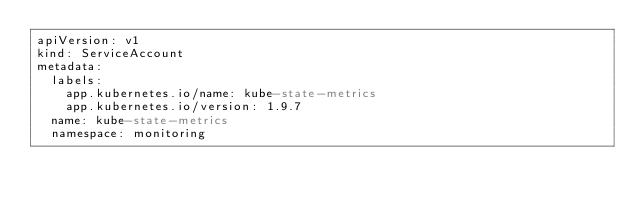<code> <loc_0><loc_0><loc_500><loc_500><_YAML_>apiVersion: v1
kind: ServiceAccount
metadata:
  labels:
    app.kubernetes.io/name: kube-state-metrics
    app.kubernetes.io/version: 1.9.7
  name: kube-state-metrics
  namespace: monitoring
</code> 